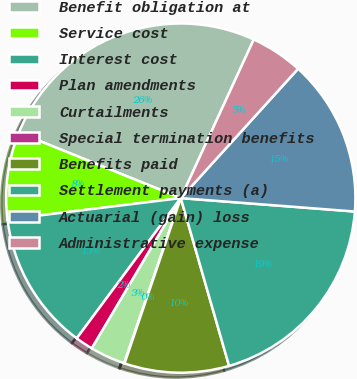Convert chart. <chart><loc_0><loc_0><loc_500><loc_500><pie_chart><fcel>Benefit obligation at<fcel>Service cost<fcel>Interest cost<fcel>Plan amendments<fcel>Curtailments<fcel>Special termination benefits<fcel>Benefits paid<fcel>Settlement payments (a)<fcel>Actuarial (gain) loss<fcel>Administrative expense<nl><fcel>25.74%<fcel>8.07%<fcel>12.89%<fcel>1.65%<fcel>3.25%<fcel>0.04%<fcel>9.68%<fcel>19.31%<fcel>14.5%<fcel>4.86%<nl></chart> 